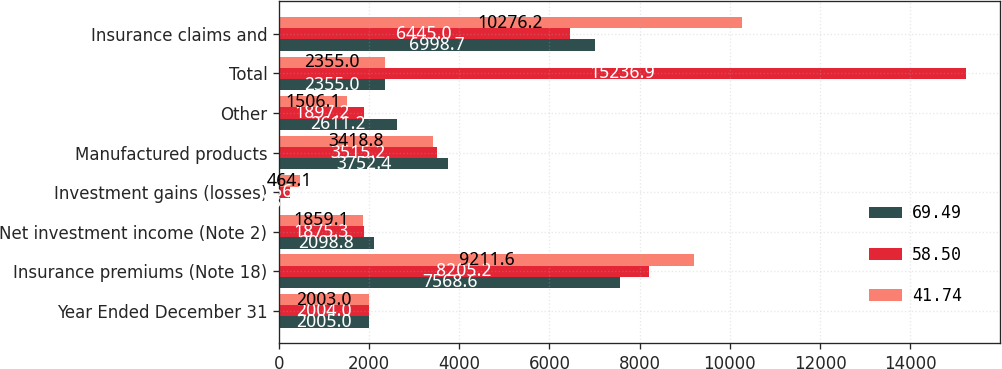Convert chart to OTSL. <chart><loc_0><loc_0><loc_500><loc_500><stacked_bar_chart><ecel><fcel>Year Ended December 31<fcel>Insurance premiums (Note 18)<fcel>Net investment income (Note 2)<fcel>Investment gains (losses)<fcel>Manufactured products<fcel>Other<fcel>Total<fcel>Insurance claims and<nl><fcel>69.49<fcel>2005<fcel>7568.6<fcel>2098.8<fcel>13.2<fcel>3752.4<fcel>2611.2<fcel>2355<fcel>6998.7<nl><fcel>58.5<fcel>2004<fcel>8205.2<fcel>1875.3<fcel>256<fcel>3515.2<fcel>1897.2<fcel>15236.9<fcel>6445<nl><fcel>41.74<fcel>2003<fcel>9211.6<fcel>1859.1<fcel>464.1<fcel>3418.8<fcel>1506.1<fcel>2355<fcel>10276.2<nl></chart> 